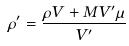<formula> <loc_0><loc_0><loc_500><loc_500>\rho ^ { \prime } = \frac { \rho V + M V ^ { \prime } \mu } { V ^ { \prime } }</formula> 